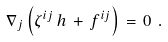Convert formula to latex. <formula><loc_0><loc_0><loc_500><loc_500>\nabla _ { j } \left ( \zeta ^ { i j } \, h \, + \, f ^ { i j } \right ) \, = \, 0 \ .</formula> 